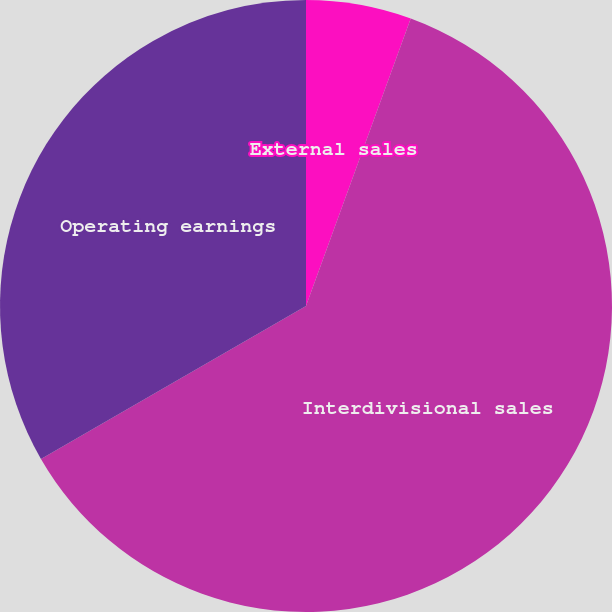<chart> <loc_0><loc_0><loc_500><loc_500><pie_chart><fcel>External sales<fcel>Interdivisional sales<fcel>Operating earnings<nl><fcel>5.56%<fcel>61.11%<fcel>33.33%<nl></chart> 